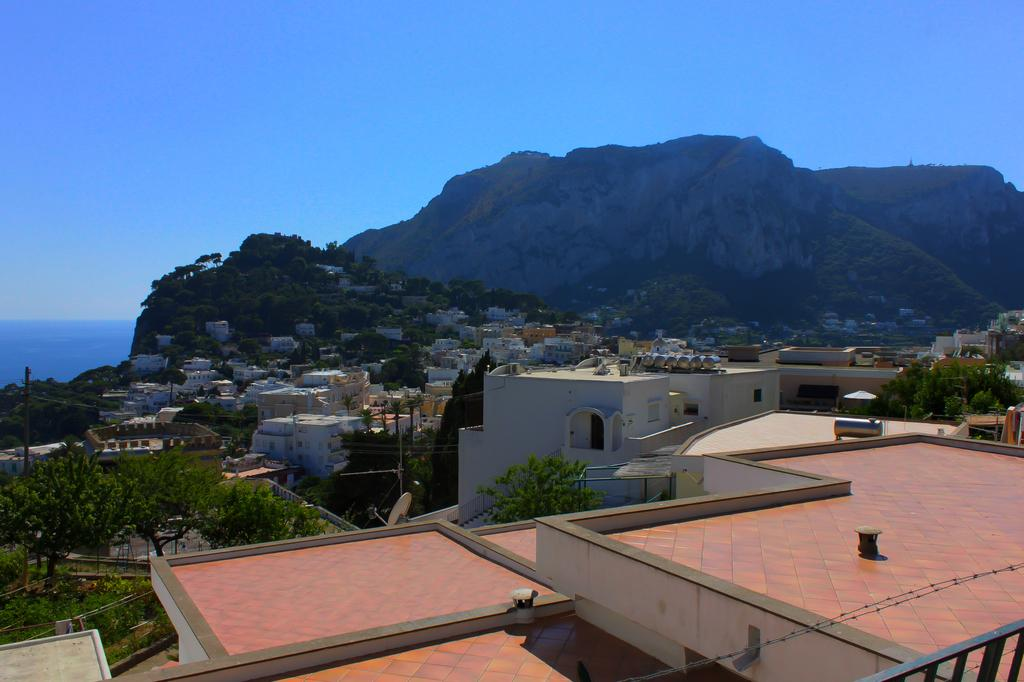What type of structures can be seen in the image? There are houses in the image. What else is present in the image besides houses? There are poles, trees, and a mountain in the image. What is visible in the background of the image? The sky is visible in the background of the image. What is the opinion of the mountain about the night sky? The mountain does not have an opinion, as it is an inanimate object and cannot express thoughts or feelings. 